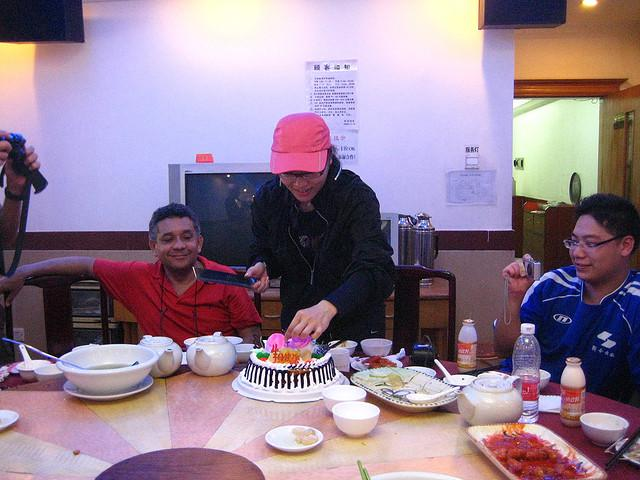What is the woman doing with the knife?

Choices:
A) sharpening
B) cutting
C) scaring
D) threatening cutting 